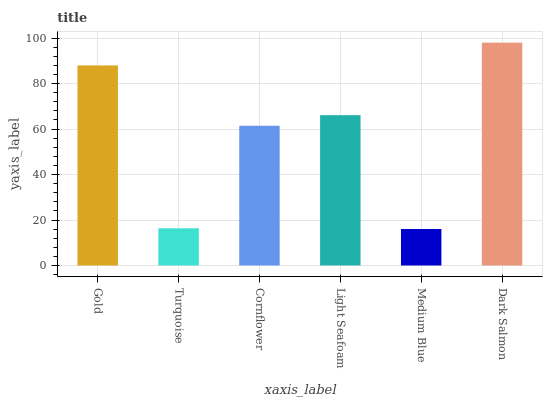Is Turquoise the minimum?
Answer yes or no. No. Is Turquoise the maximum?
Answer yes or no. No. Is Gold greater than Turquoise?
Answer yes or no. Yes. Is Turquoise less than Gold?
Answer yes or no. Yes. Is Turquoise greater than Gold?
Answer yes or no. No. Is Gold less than Turquoise?
Answer yes or no. No. Is Light Seafoam the high median?
Answer yes or no. Yes. Is Cornflower the low median?
Answer yes or no. Yes. Is Dark Salmon the high median?
Answer yes or no. No. Is Turquoise the low median?
Answer yes or no. No. 